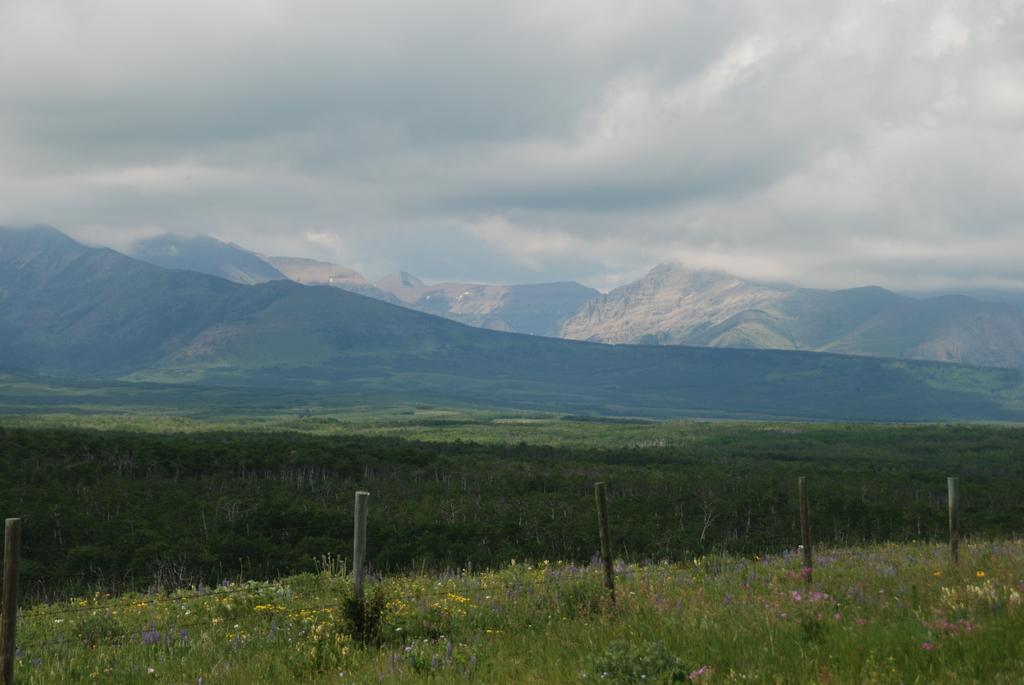How would you summarize this image in a sentence or two? In this picture we can observe some poles on the ground. There are some plants and grass on the land. In the background there are hills and a sky with clouds. 